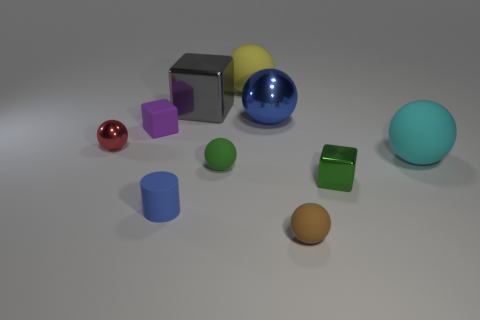Subtract all green matte spheres. How many spheres are left? 5 Subtract all cyan balls. How many balls are left? 5 Subtract 1 cubes. How many cubes are left? 2 Subtract all cylinders. How many objects are left? 9 Subtract all green spheres. Subtract all yellow cylinders. How many spheres are left? 5 Add 1 small shiny things. How many small shiny things are left? 3 Add 1 tiny red shiny objects. How many tiny red shiny objects exist? 2 Subtract 0 purple cylinders. How many objects are left? 10 Subtract all small red things. Subtract all small brown things. How many objects are left? 8 